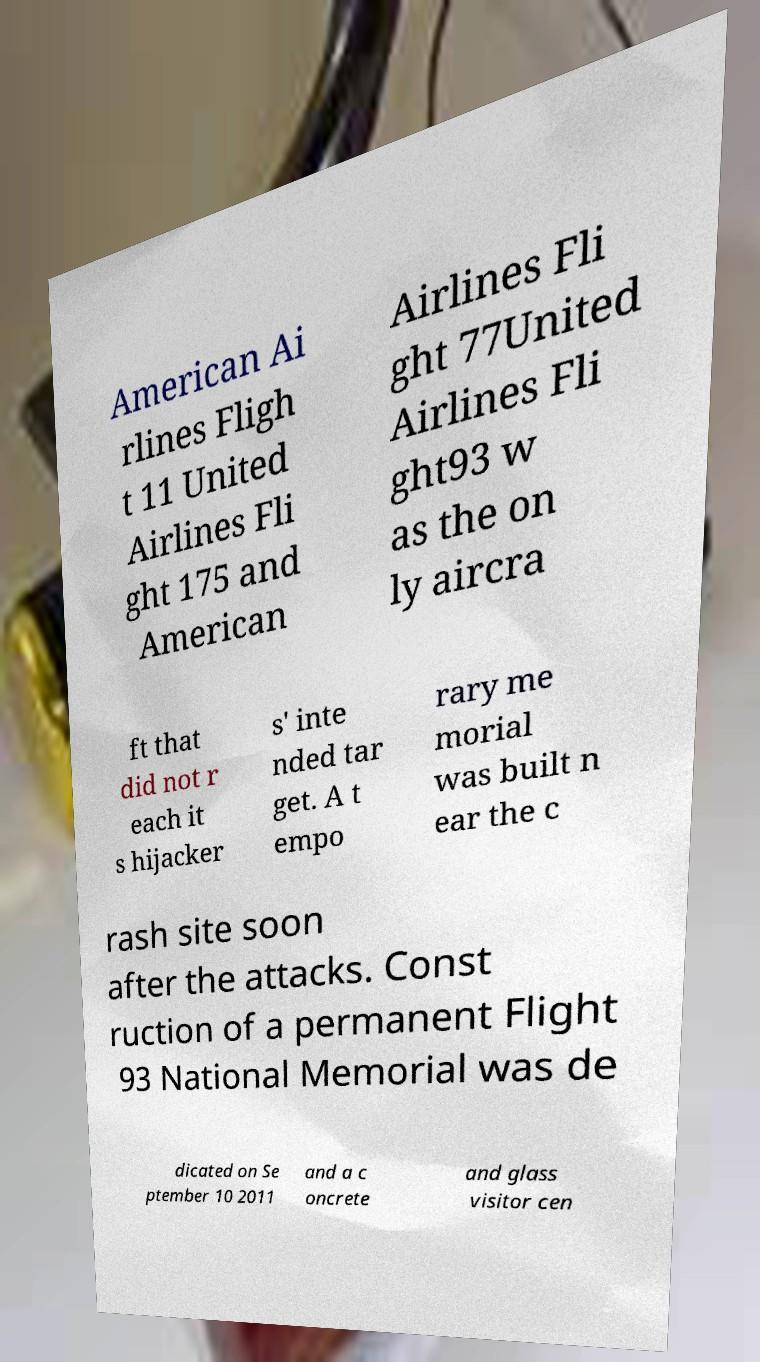Can you read and provide the text displayed in the image?This photo seems to have some interesting text. Can you extract and type it out for me? American Ai rlines Fligh t 11 United Airlines Fli ght 175 and American Airlines Fli ght 77United Airlines Fli ght93 w as the on ly aircra ft that did not r each it s hijacker s' inte nded tar get. A t empo rary me morial was built n ear the c rash site soon after the attacks. Const ruction of a permanent Flight 93 National Memorial was de dicated on Se ptember 10 2011 and a c oncrete and glass visitor cen 